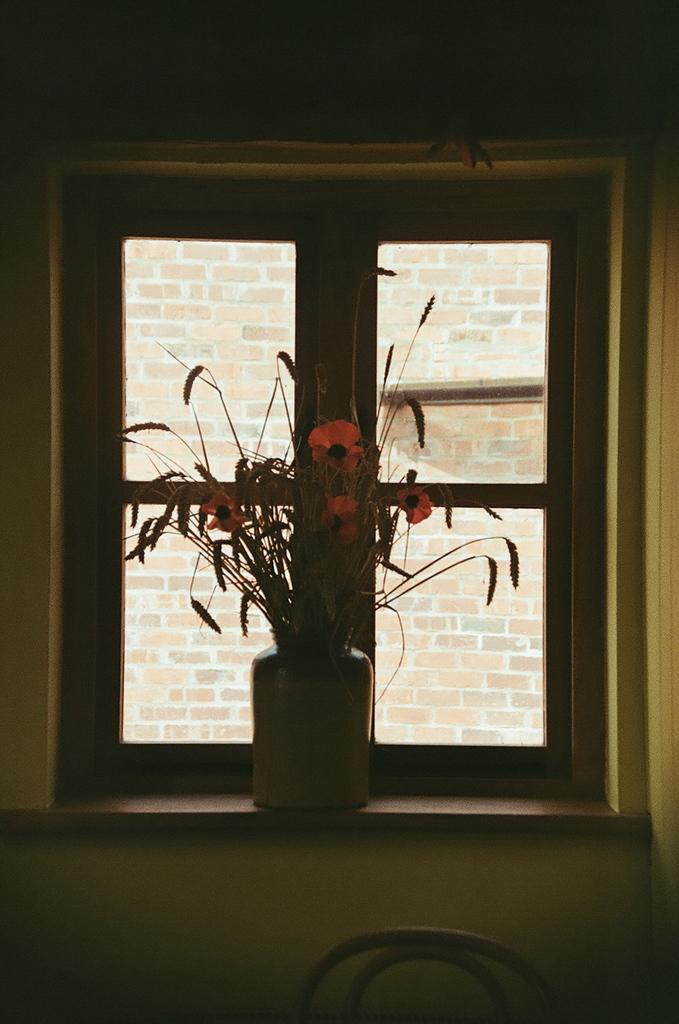What object is present in the image that might hold plants? There is a flower pot in the image. What architectural feature is visible in the image? There is a window in the image. What can be seen outside the window in the image? There is a brick wall visible outside the window. How many pets are visible inside the flower pot in the image? There are no pets visible inside the flower pot in the image. What type of face can be seen on the brick wall outside the window? There is no face visible on the brick wall outside the window in the image. 